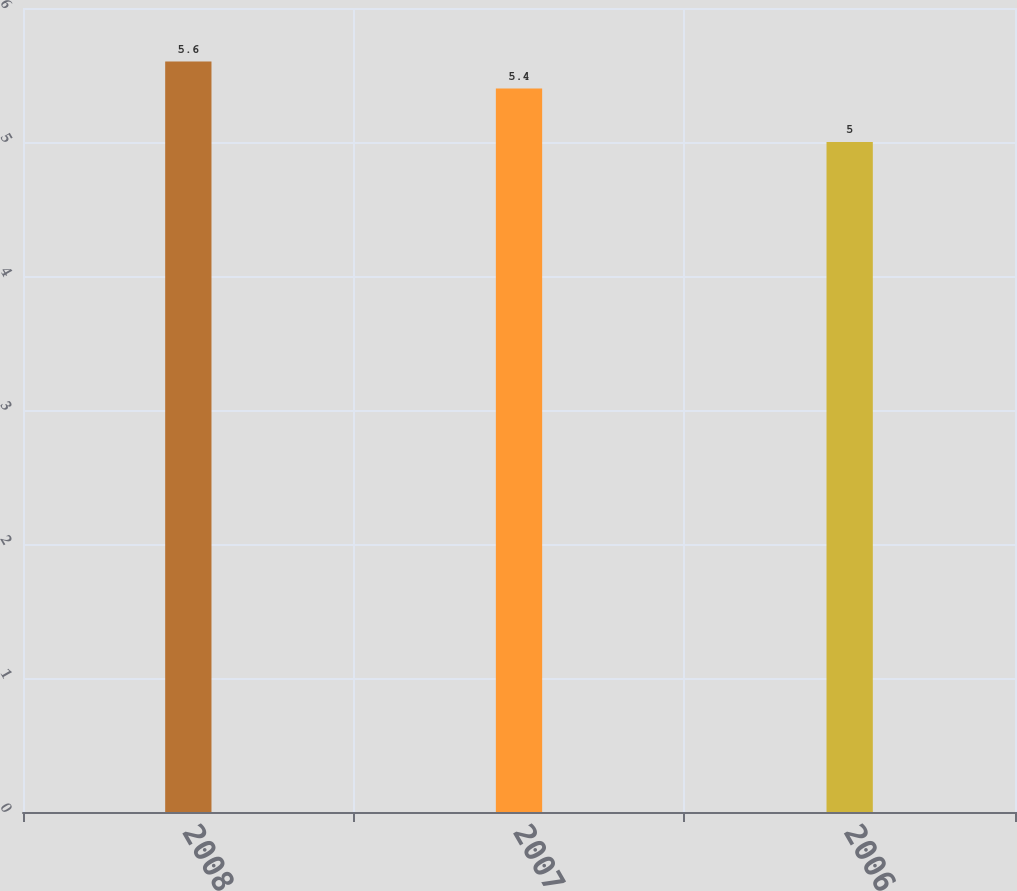<chart> <loc_0><loc_0><loc_500><loc_500><bar_chart><fcel>2008<fcel>2007<fcel>2006<nl><fcel>5.6<fcel>5.4<fcel>5<nl></chart> 